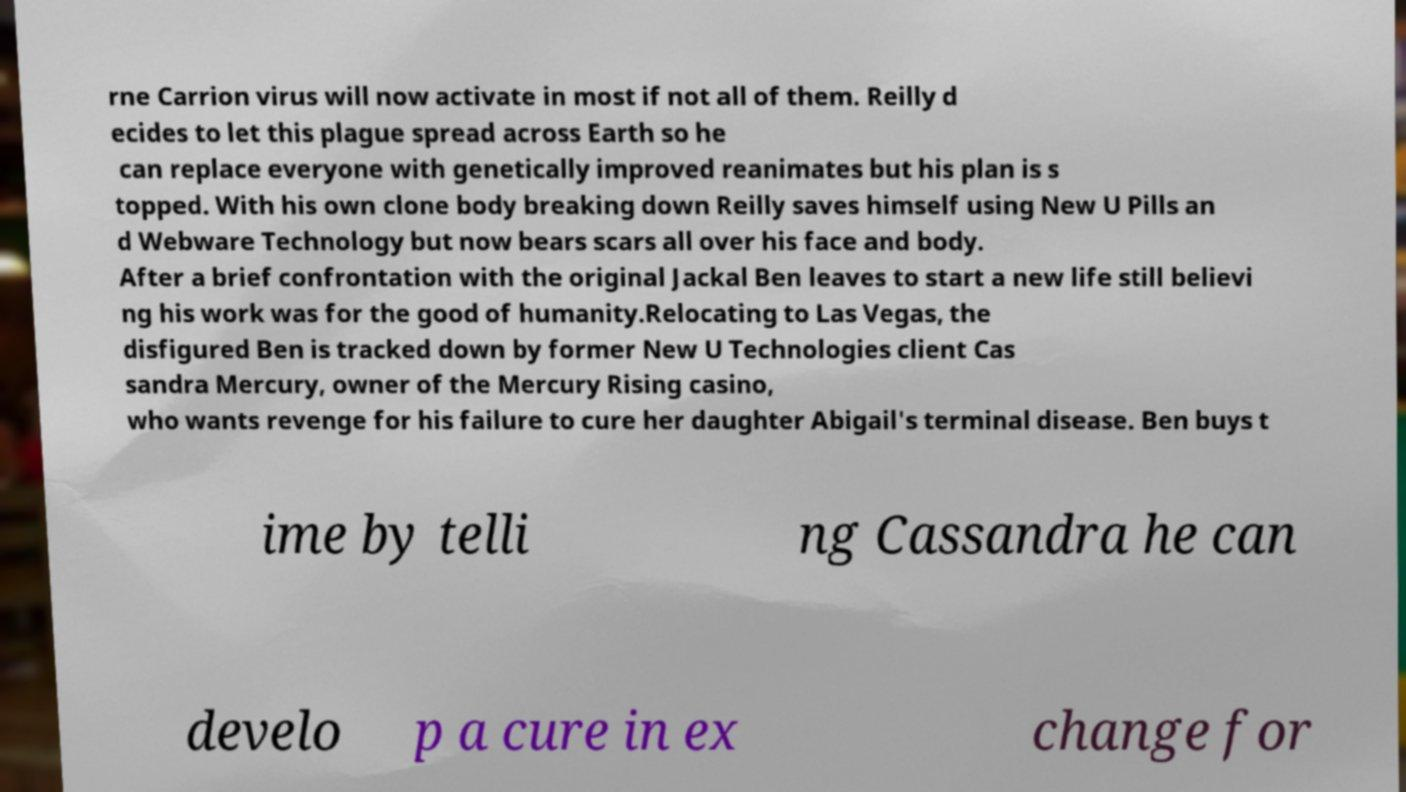There's text embedded in this image that I need extracted. Can you transcribe it verbatim? rne Carrion virus will now activate in most if not all of them. Reilly d ecides to let this plague spread across Earth so he can replace everyone with genetically improved reanimates but his plan is s topped. With his own clone body breaking down Reilly saves himself using New U Pills an d Webware Technology but now bears scars all over his face and body. After a brief confrontation with the original Jackal Ben leaves to start a new life still believi ng his work was for the good of humanity.Relocating to Las Vegas, the disfigured Ben is tracked down by former New U Technologies client Cas sandra Mercury, owner of the Mercury Rising casino, who wants revenge for his failure to cure her daughter Abigail's terminal disease. Ben buys t ime by telli ng Cassandra he can develo p a cure in ex change for 